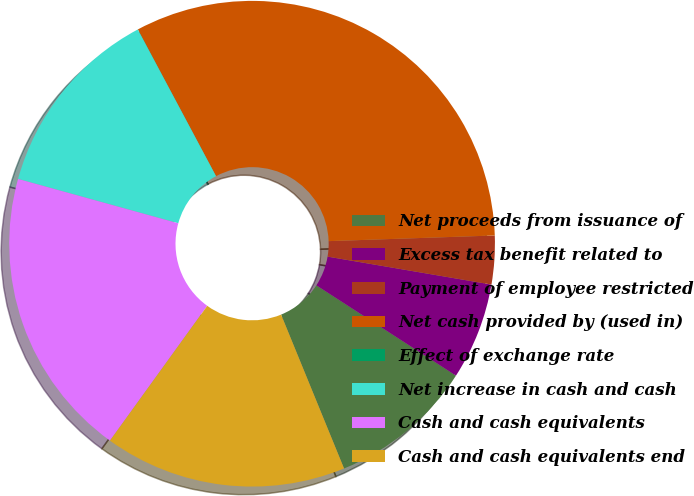Convert chart. <chart><loc_0><loc_0><loc_500><loc_500><pie_chart><fcel>Net proceeds from issuance of<fcel>Excess tax benefit related to<fcel>Payment of employee restricted<fcel>Net cash provided by (used in)<fcel>Effect of exchange rate<fcel>Net increase in cash and cash<fcel>Cash and cash equivalents<fcel>Cash and cash equivalents end<nl><fcel>9.68%<fcel>6.45%<fcel>3.23%<fcel>32.25%<fcel>0.01%<fcel>12.9%<fcel>19.35%<fcel>16.13%<nl></chart> 